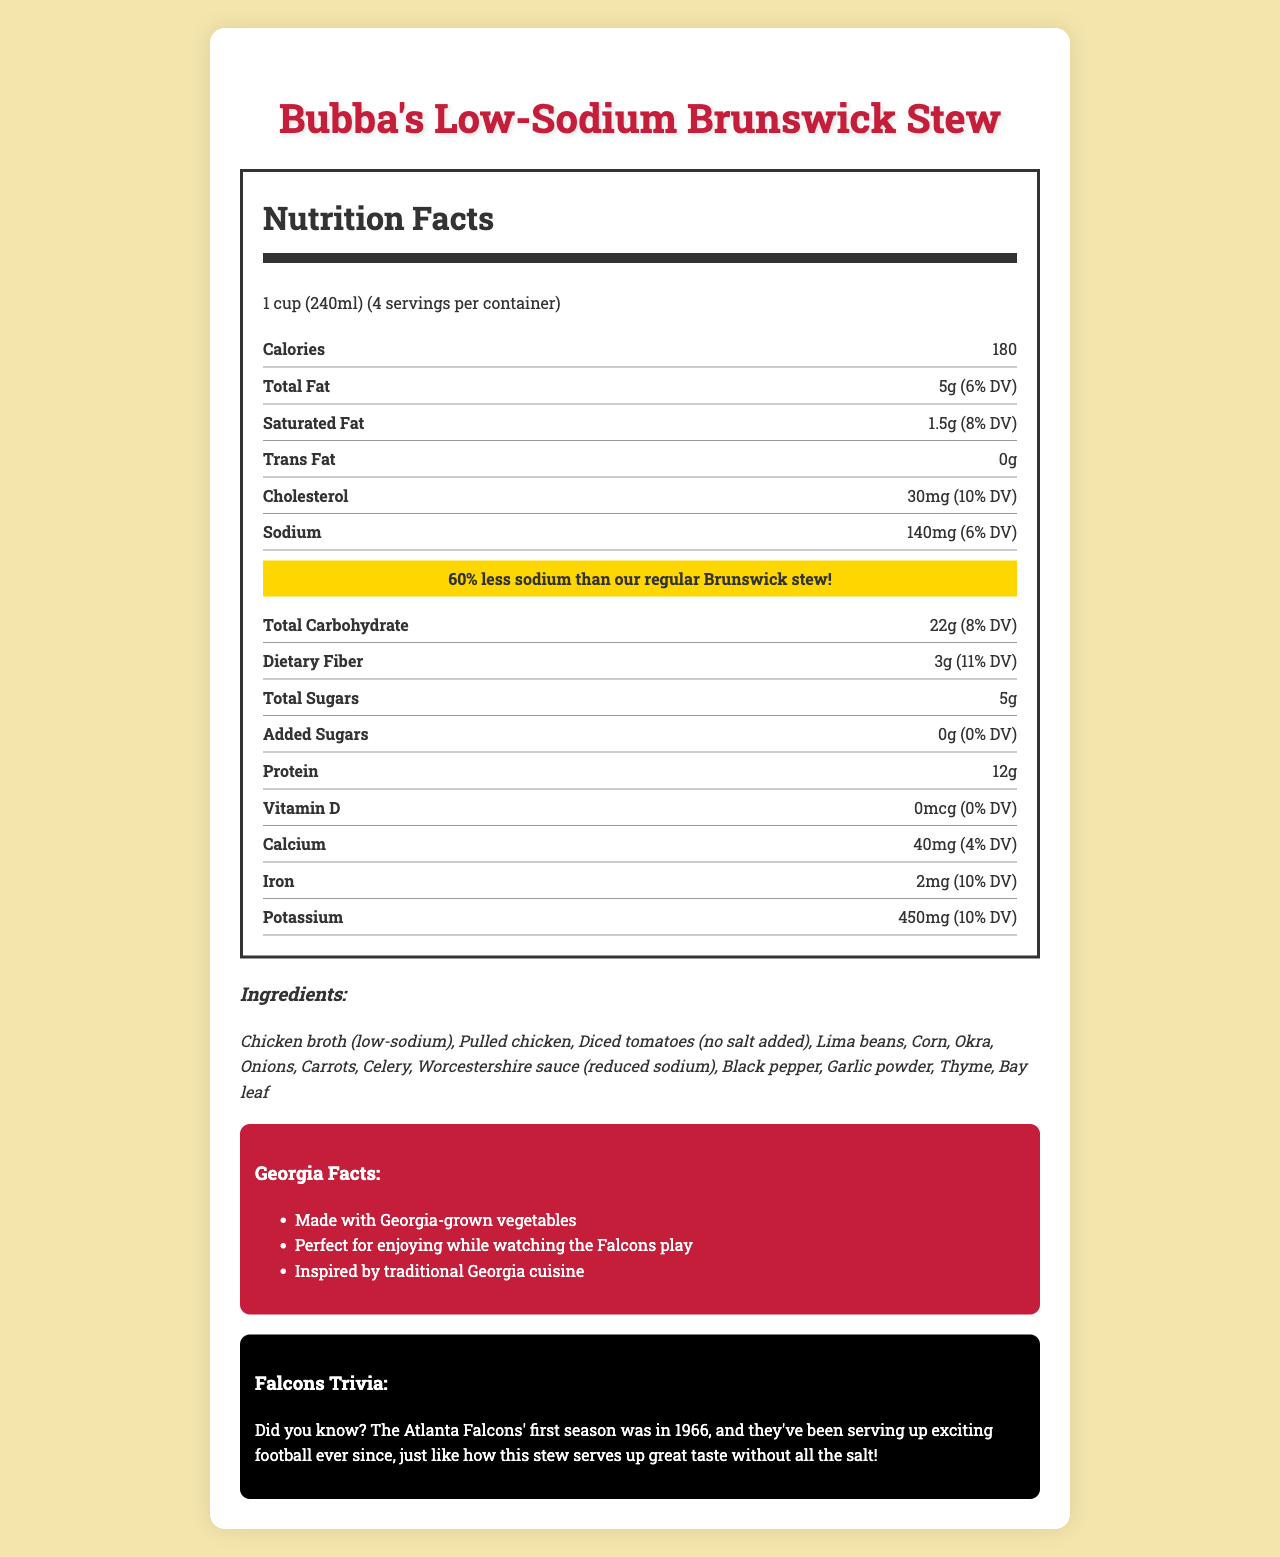what is the serving size of Bubba's Low-Sodium Brunswick Stew? According to the document, the serving size is clearly stated as 1 cup (240ml).
Answer: 1 cup (240ml) how many servings are in one container of Bubba's Low-Sodium Brunswick Stew? The document states that there are 4 servings per container.
Answer: 4 how many calories does one serving of this stew contain? The document mentions that each serving contains 180 calories.
Answer: 180 how much total fat is in one serving (in grams)? The document lists the total fat content as 5 grams per serving.
Answer: 5g what percentage of the daily value (DV) is the sodium content? The document shows that the sodium content constitutes 6% of the daily value.
Answer: 6% which ingredient listed is specifically noted to be 'no salt added'? The ingredients section specifies "Diced tomatoes (no salt added)".
Answer: Diced tomatoes how much less sodium does this stew have compared to regular Brunswick stew? The document highlights that this stew has 60% less sodium than the regular version.
Answer: 60% less sodium what is the daily value percentage of protein provided in one serving? As per the document, one serving of the stew provides 24% of the daily value of protein.
Answer: 24% which nutrient has a daily value of 4% in one serving? A. Iron B. Calcium C. Potassium D. Vitamin D The calcium content has a daily value of 4% in one serving.
Answer: B. Calcium which of the following is NOT an ingredient in Bubba's Low-Sodium Brunswick Stew? I. Lima Beans II. Potatoes III. Okra IV. Carrots The ingredients listed in the document do not include potatoes.
Answer: II. Potatoes is there any iron in Bubba's Low-Sodium Brunswick Stew? The document lists iron content as 2mg per serving, constituting 10% of the daily value.
Answer: Yes describe the main idea of the document. The document combines nutritional details, ingredient lists, and local trivia to offer comprehensive information about Bubba's Low-Sodium Brunswick Stew. It emphasizes the stew's health benefits, particularly its lower sodium content, while engaging readers with facts about Georgia and the Falcons.
Answer: The document provides detailed nutrition information for Bubba's Low-Sodium Brunswick Stew, highlighting its reduced sodium content and its ingredients. It also includes fun facts about Georgia and the Atlanta Falcons to appeal to local consumers. is there any allergen information provided in the document? The document mentions the allergen information section and states "Contains: None."
Answer: Yes how many Georgia facts are listed in the document? The Georgia facts section lists three facts about the stew and its connection to Georgia.
Answer: 3 what year did the Atlanta Falcons have their first season? According to the Falcons trivia section, the Atlanta Falcons' first season was in 1966.
Answer: 1966 what is the sodium content in milligrams per serving? The document specifies that the sodium content per serving is 140mg.
Answer: 140mg what is the main type of meat used in Bubba's Low-Sodium Brunswick Stew? The ingredients section lists pulled chicken as one of the main ingredients.
Answer: Pulled chicken does the document specify the amount of vitamin D in the stew? The document lists the vitamin D content as 0 mcg per serving.
Answer: Yes is there any mention of the stew being recommended for a particular activity or event? The document suggests that the stew is perfect for enjoying while watching the Falcons play.
Answer: Yes does the document provide information on the sugar content of the stew? The document shows that the total sugars per serving amount to 5g, with 0g of added sugars.
Answer: Yes what is the contact information for the manufacturer? The document does not provide any contact information for the manufacturer, so it's not possible to determine this from the visual information given.
Answer: Cannot be determined 